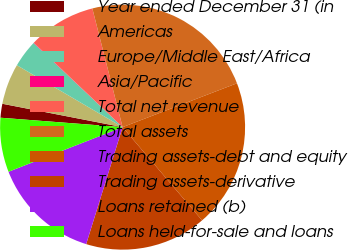Convert chart to OTSL. <chart><loc_0><loc_0><loc_500><loc_500><pie_chart><fcel>Year ended December 31 (in<fcel>Americas<fcel>Europe/Middle East/Africa<fcel>Asia/Pacific<fcel>Total net revenue<fcel>Total assets<fcel>Trading assets-debt and equity<fcel>Trading assets-derivative<fcel>Loans retained (b)<fcel>Loans held-for-sale and loans<nl><fcel>1.83%<fcel>5.38%<fcel>3.61%<fcel>0.05%<fcel>8.93%<fcel>23.14%<fcel>19.59%<fcel>16.04%<fcel>14.26%<fcel>7.16%<nl></chart> 